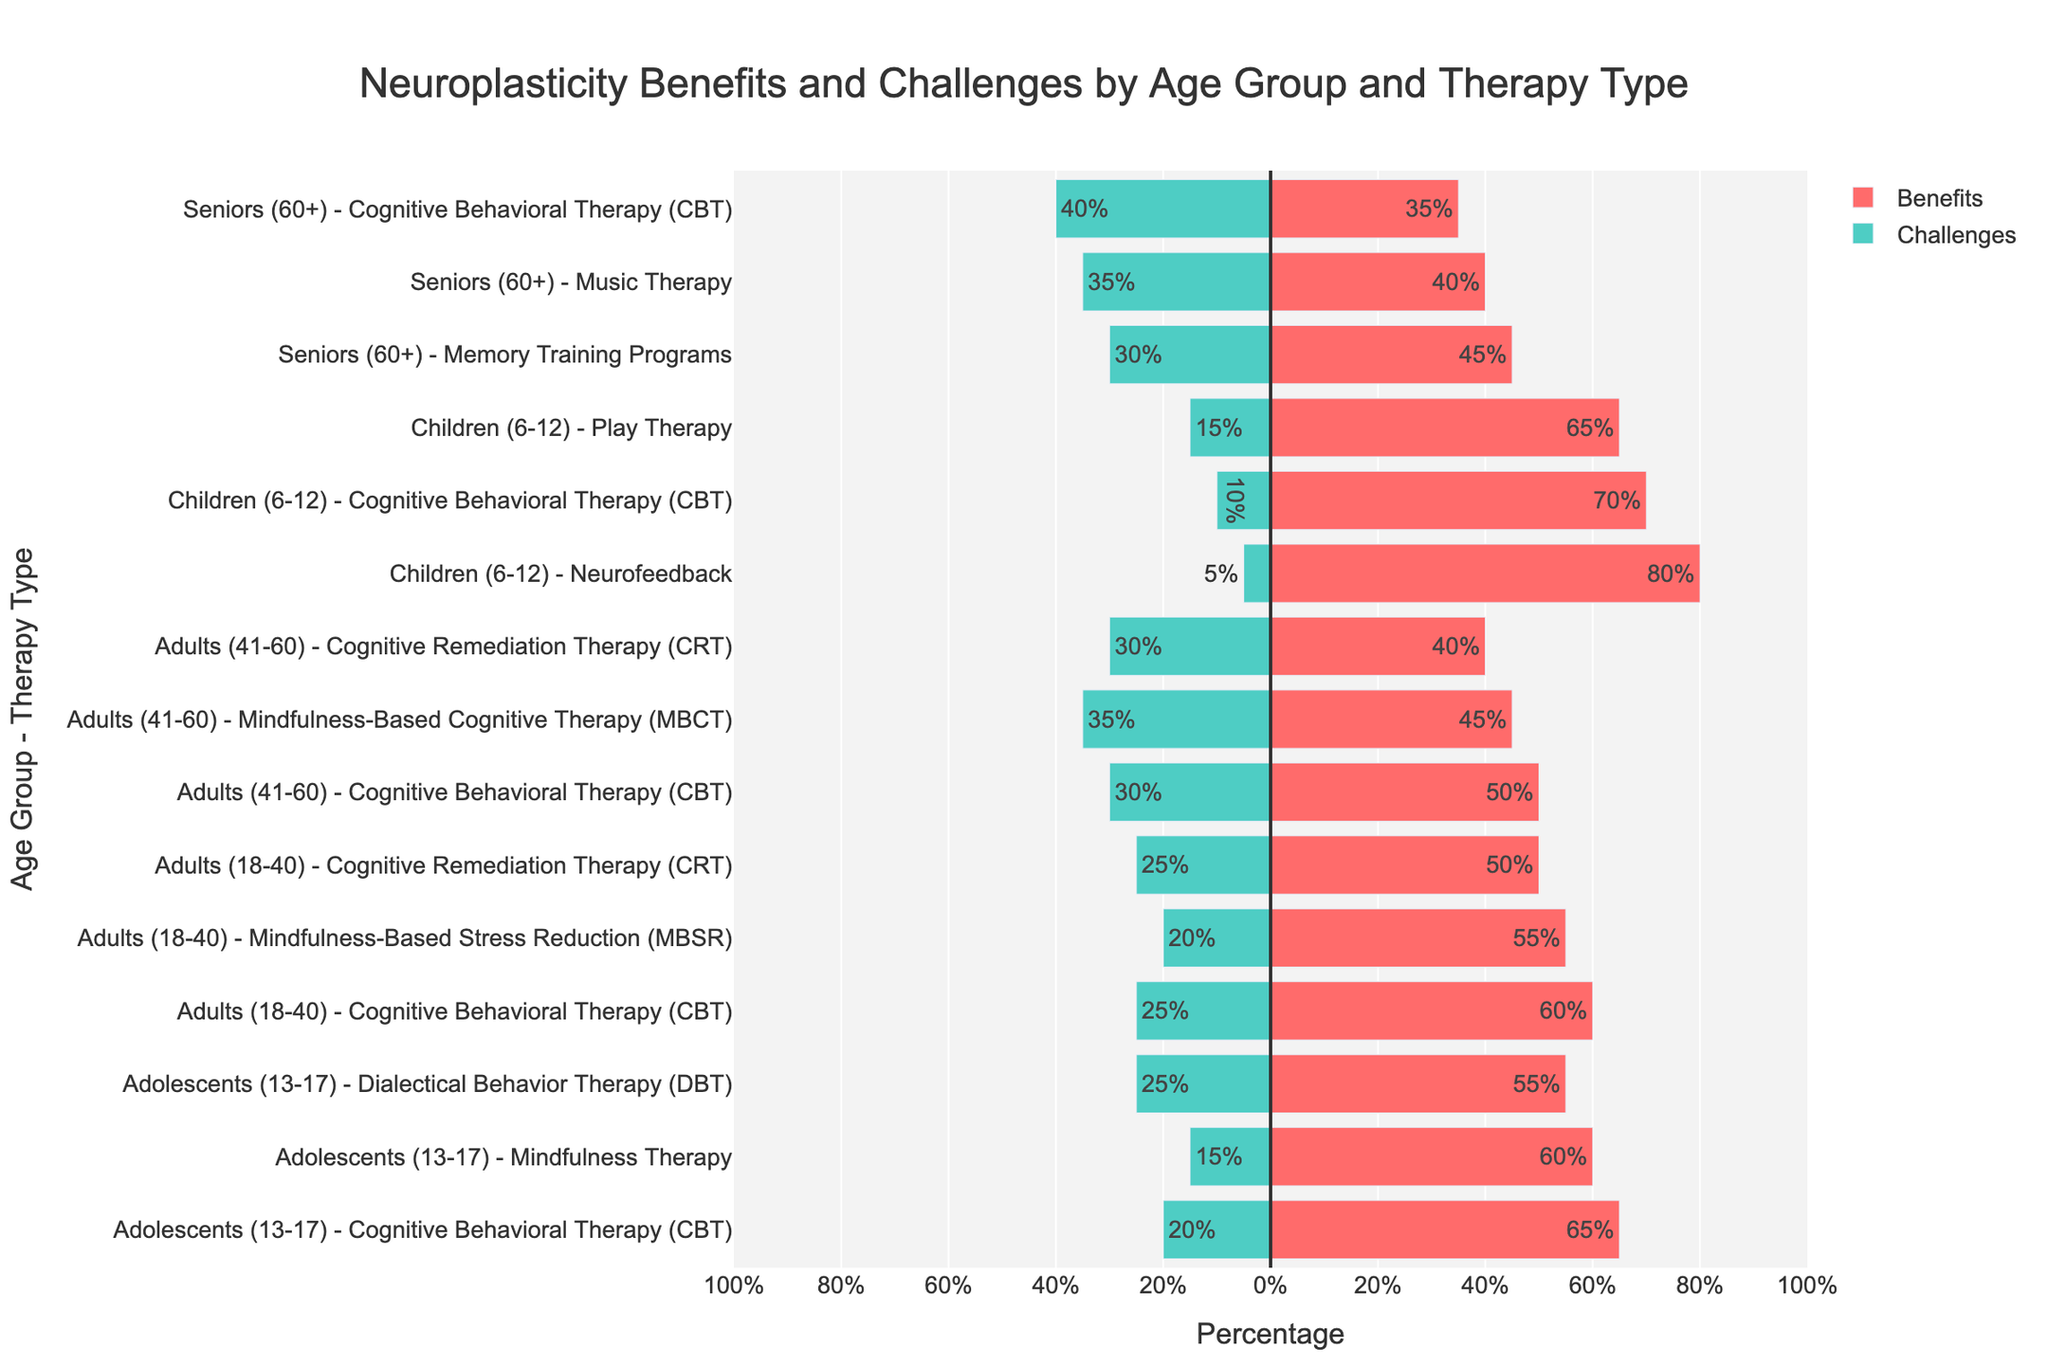Which therapy type for children (6-12) shows the highest neuroplasticity benefit? By observing the "Children (6-12)" age group in the figure, we see that "Neurofeedback" has the longest bar in the positive direction indicating the benefit.
Answer: Neurofeedback Which therapy type for seniors (60+) has the highest neuroplasticity challenge? Within the "Seniors (60+)" age group, the "Cognitive Behavioral Therapy (CBT)" bar extends the furthest into the negative side, denoting the highest challenge.
Answer: Cognitive Behavioral Therapy (CBT) Compare the neuroplasticity benefit percentages of Cognitive Behavioral Therapy (CBT) across all age groups. Which age group shows the highest benefit? By comparing the bars for "Cognitive Behavioral Therapy (CBT)" across all age groups, we observe that "Children (6-12)" has the highest neuroplasticity benefit.
Answer: Children (6-12) What is the total neuroplasticity challenge percentage for the therapy types in the Adolescents (13-17) age group? Sum the negative values for the "Adolescents (13-17)" age group: CBT (-20) + DBT (-25) + Mindfulness (-15). -20 + -25 + -15 = -60%.
Answer: -60% Which therapy type shows a higher neuroplasticity benefit: Mindfulness-Based Stress Reduction (MBSR) for Adults (18-40) or Mindfulness-Based Cognitive Therapy (MBCT) for Adults (41-60)? Comparing the positive bars for these two therapies, MBSR for Adults (18-40) is at 55% and MBCT for Adults (41-60) is at 45%. MBSR has a higher benefit.
Answer: Mindfulness-Based Stress Reduction (MBSR) for Adults (18-40) What is the average neuroplasticity benefit for therapies in the "Adults (41-60)" age group? The benefits in Adults (41-60) are CBT (50%), MBCT (45%), and CRT (40%). The average is (50 + 45 + 40) / 3 = 45%.
Answer: 45% For the "Children (6-12)" group, how much greater is the neuroplasticity benefit for Neurofeedback compared to Play Therapy? Neurofeedback has a benefit of 80%, and Play Therapy has 65%. The difference is 80 - 65 = 15%.
Answer: 15% In the "Seniors (60+)" age group, which therapy type has a smaller neuroplasticity challenge: Music Therapy or Memory Training Programs? Comparing the negative bars, Memory Training Programs (-30%) has a smaller challenge compared to Music Therapy (-35%).
Answer: Memory Training Programs Which age group has the smallest difference between the highest and lowest neuroplasticity benefits among all therapy types? By calculating the difference in benefits for each age group, the differences are:
- Children (6-12): 80% - 65% = 15%
- Adolescents (13-17): 65% - 55% = 10%
- Adults (18-40): 60% - 50% = 10%
- Adults (41-60): 50% - 40% = 10%
- Seniors (60+): 45% - 35% = 10%.
The smallest difference is 10%, shared by several groups.
Answer: Adolescents (13-17), Adults (18-40), Adults (41-60), Seniors (60+) What is the combined neuroplasticity benefit percentage for all therapies in the "Children (6-12)" group? Sum the benefit values: 70 (CBT) + 65 (Play Therapy) + 80 (Neurofeedback) = 215%.
Answer: 215% 